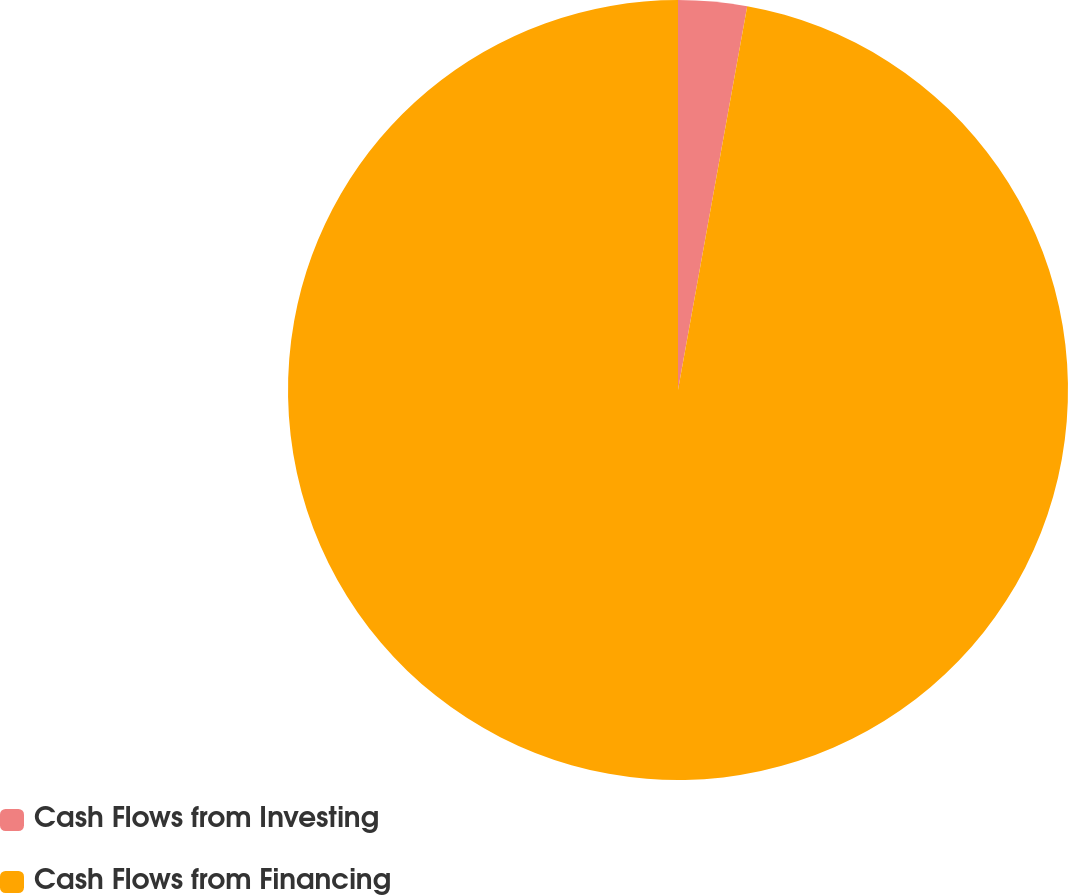Convert chart. <chart><loc_0><loc_0><loc_500><loc_500><pie_chart><fcel>Cash Flows from Investing<fcel>Cash Flows from Financing<nl><fcel>2.84%<fcel>97.16%<nl></chart> 